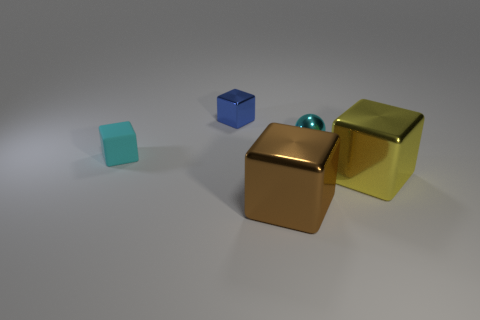Add 1 tiny blue shiny cubes. How many objects exist? 6 Subtract all balls. How many objects are left? 4 Subtract all brown things. Subtract all yellow metallic cubes. How many objects are left? 3 Add 3 matte cubes. How many matte cubes are left? 4 Add 5 tiny green objects. How many tiny green objects exist? 5 Subtract 1 blue blocks. How many objects are left? 4 